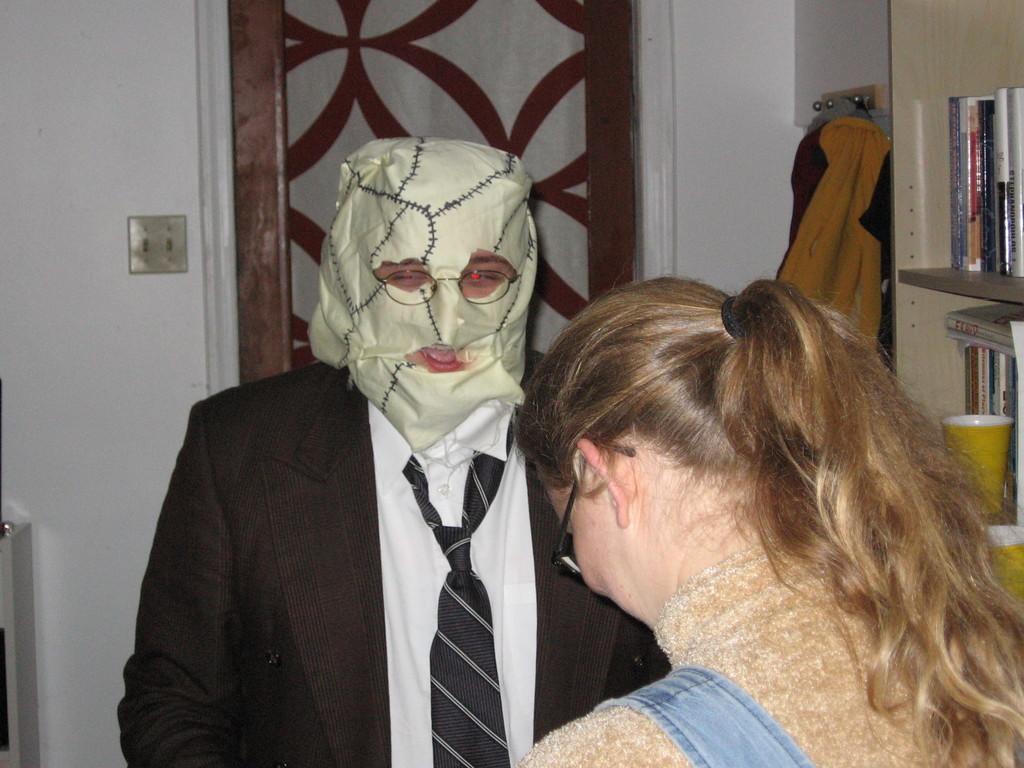How would you summarize this image in a sentence or two? In this image, we can see a man and a woman standing, the man is wearing a mask on the face, we can see a rack on the right, there are some books kept in the rack, in the background we can see a door and a wall. 